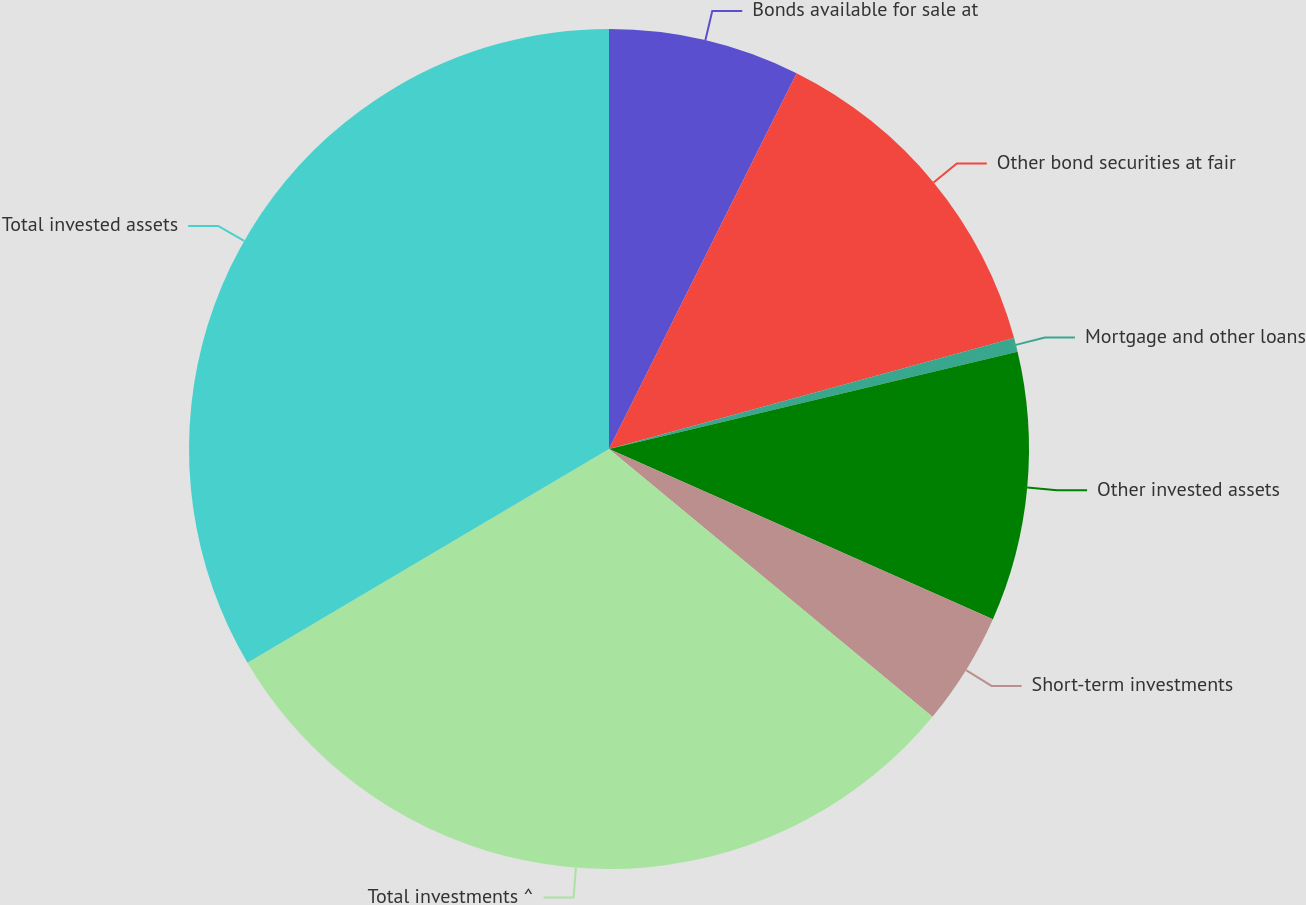Convert chart. <chart><loc_0><loc_0><loc_500><loc_500><pie_chart><fcel>Bonds available for sale at<fcel>Other bond securities at fair<fcel>Mortgage and other loans<fcel>Other invested assets<fcel>Short-term investments<fcel>Total investments ^<fcel>Total invested assets<nl><fcel>7.37%<fcel>13.38%<fcel>0.53%<fcel>10.37%<fcel>4.36%<fcel>30.5%<fcel>33.5%<nl></chart> 